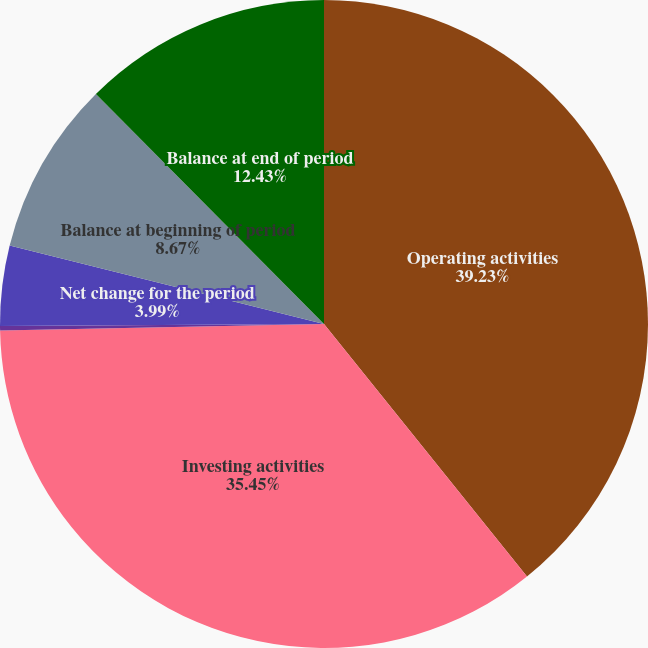Convert chart. <chart><loc_0><loc_0><loc_500><loc_500><pie_chart><fcel>Operating activities<fcel>Investing activities<fcel>Financing activities<fcel>Net change for the period<fcel>Balance at beginning of period<fcel>Balance at end of period<nl><fcel>39.22%<fcel>35.45%<fcel>0.23%<fcel>3.99%<fcel>8.67%<fcel>12.43%<nl></chart> 